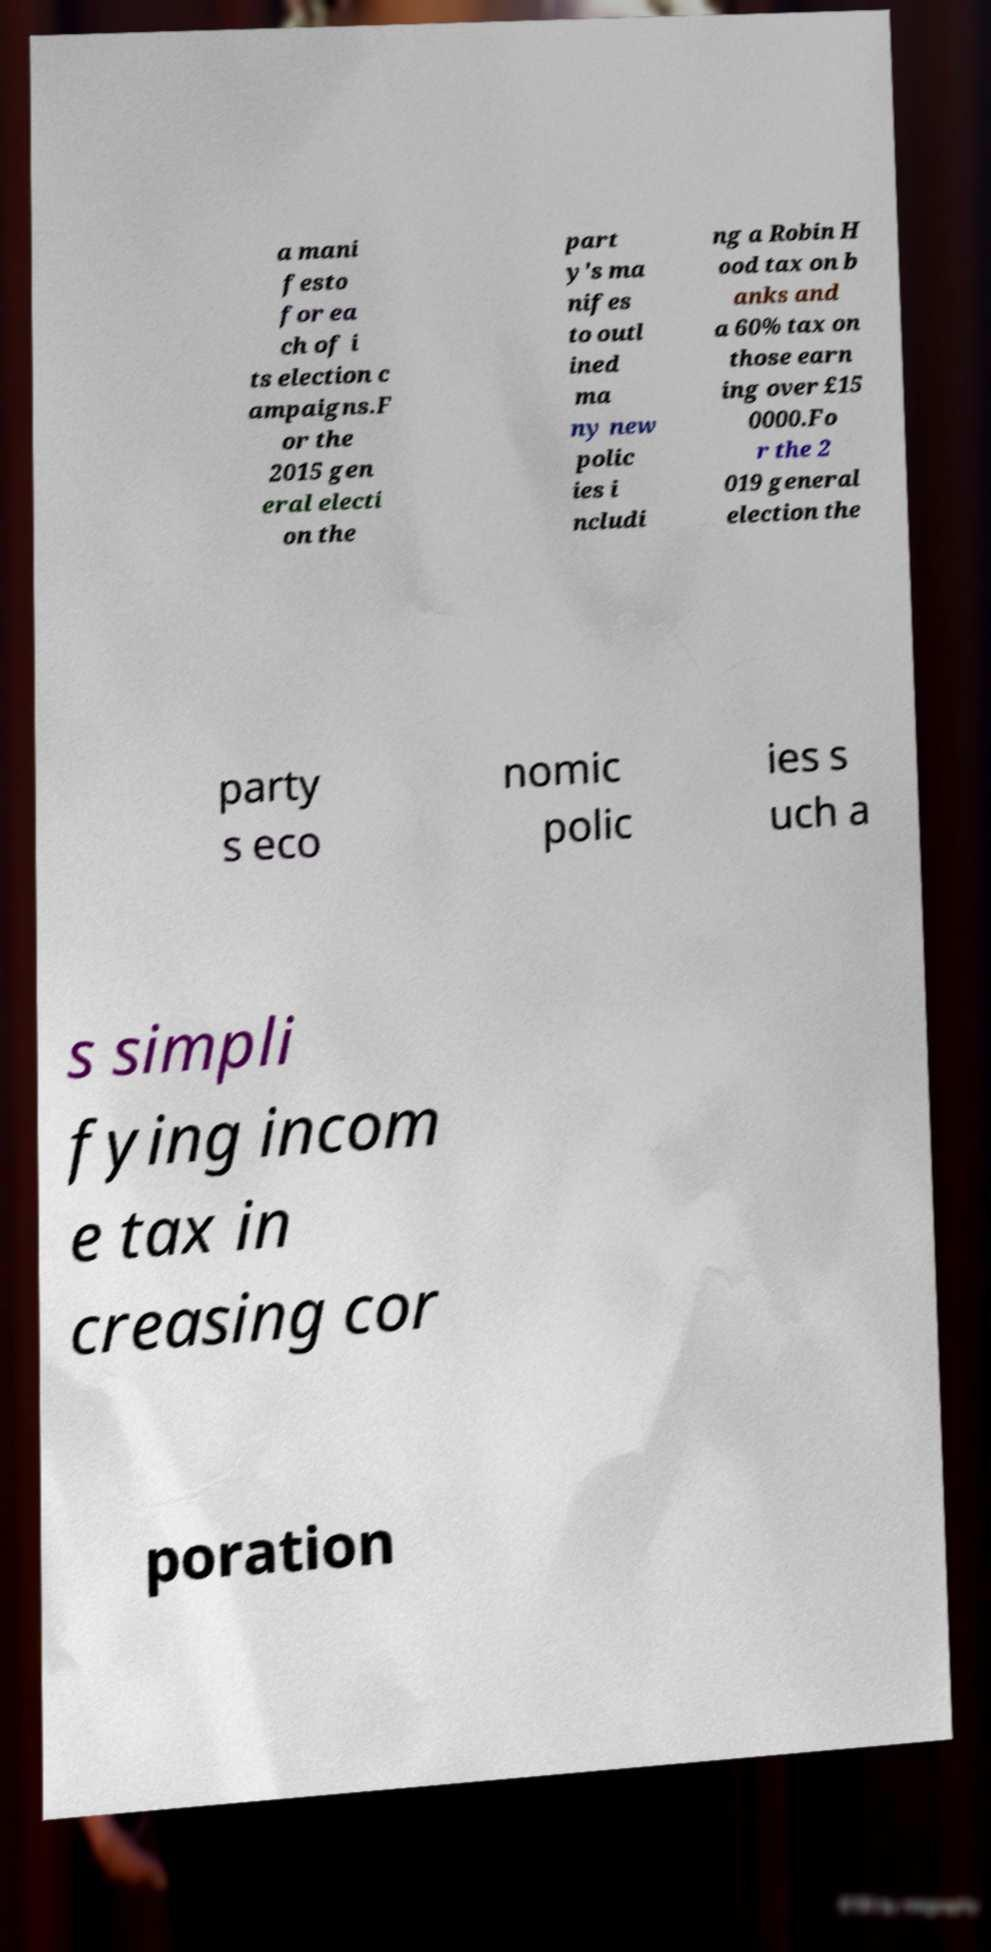Could you assist in decoding the text presented in this image and type it out clearly? a mani festo for ea ch of i ts election c ampaigns.F or the 2015 gen eral electi on the part y's ma nifes to outl ined ma ny new polic ies i ncludi ng a Robin H ood tax on b anks and a 60% tax on those earn ing over £15 0000.Fo r the 2 019 general election the party s eco nomic polic ies s uch a s simpli fying incom e tax in creasing cor poration 